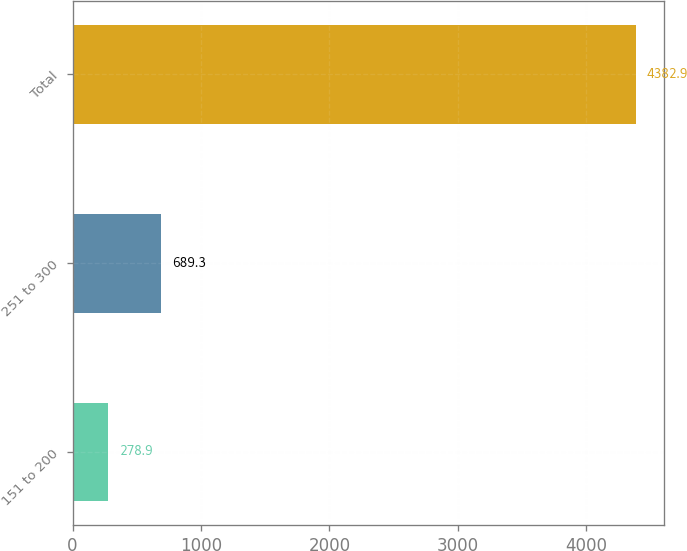Convert chart. <chart><loc_0><loc_0><loc_500><loc_500><bar_chart><fcel>151 to 200<fcel>251 to 300<fcel>Total<nl><fcel>278.9<fcel>689.3<fcel>4382.9<nl></chart> 